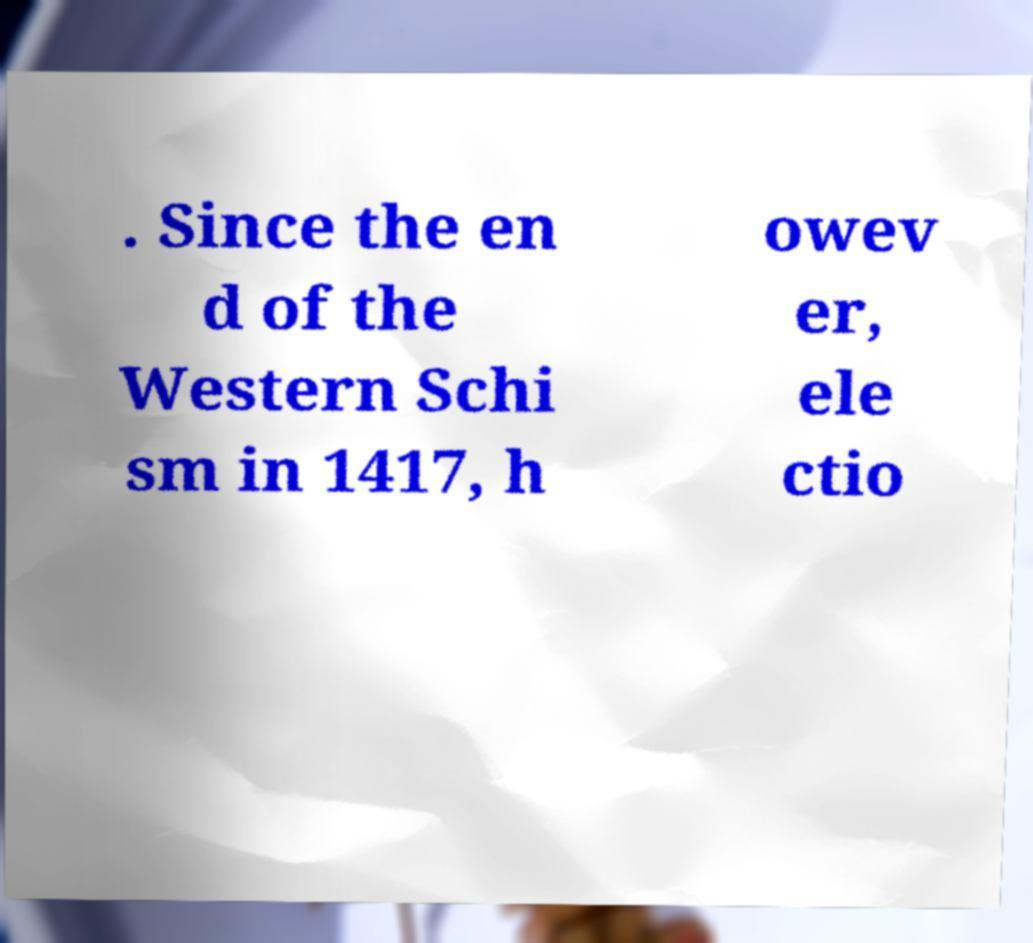What messages or text are displayed in this image? I need them in a readable, typed format. . Since the en d of the Western Schi sm in 1417, h owev er, ele ctio 